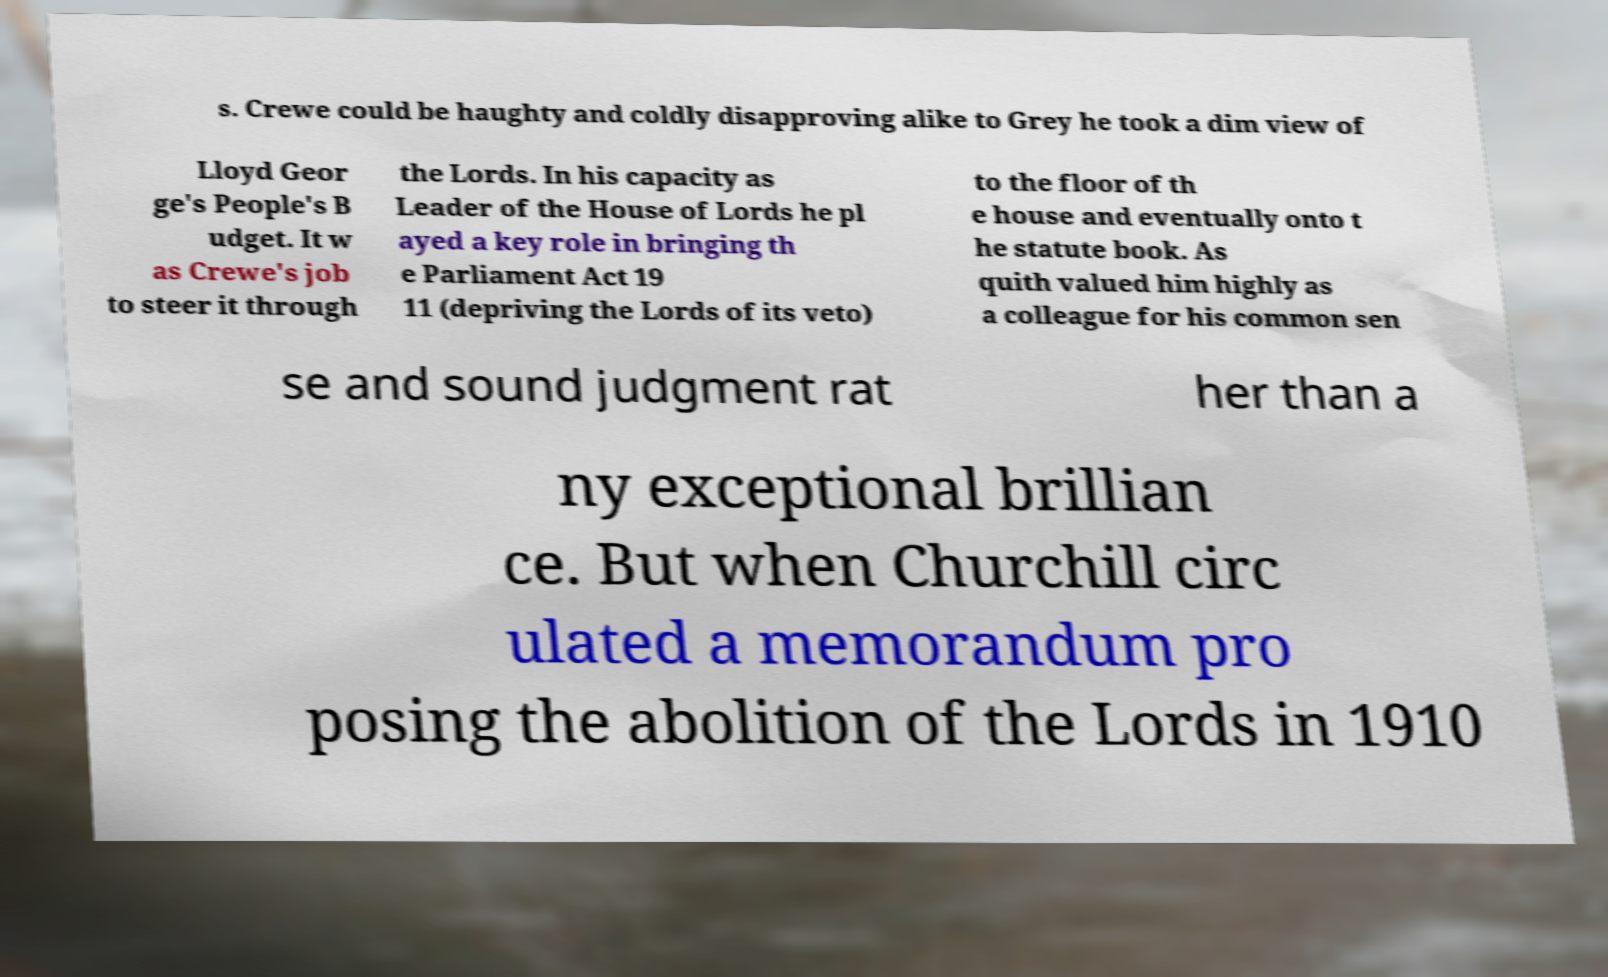Can you accurately transcribe the text from the provided image for me? s. Crewe could be haughty and coldly disapproving alike to Grey he took a dim view of Lloyd Geor ge's People's B udget. It w as Crewe's job to steer it through the Lords. In his capacity as Leader of the House of Lords he pl ayed a key role in bringing th e Parliament Act 19 11 (depriving the Lords of its veto) to the floor of th e house and eventually onto t he statute book. As quith valued him highly as a colleague for his common sen se and sound judgment rat her than a ny exceptional brillian ce. But when Churchill circ ulated a memorandum pro posing the abolition of the Lords in 1910 